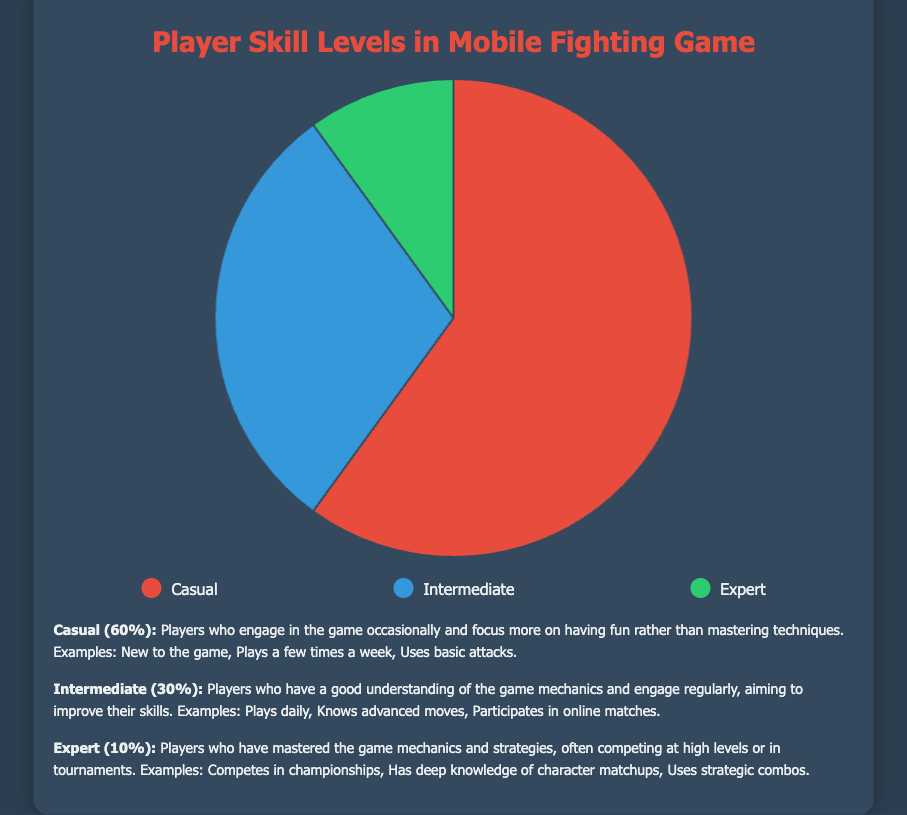Which skill level has the highest percentage of players? By examining the pie chart, it is evident that the "Casual" category is the largest segment of the pie chart, indicating it has the highest percentage.
Answer: Casual What percentage of players are either Intermediate or Expert? To find the combined percentage of Intermediate and Expert players, add their respective percentages: 30% (Intermediate) + 10% (Expert) = 40%.
Answer: 40% How much smaller is the percentage of Expert players compared to Casual players? Subtract the percentage of Expert players from Casual players: 60% (Casual) - 10% (Expert) = 50%.
Answer: 50% Which skill level is represented by the green color in the chart? Observing the pie chart legend, the green color corresponds to the "Expert" category.
Answer: Expert What is the ratio of Casual players to Intermediate players? The ratio can be determined by dividing the percentage of Casual players by the percentage of Intermediate players: 60% / 30% = 2:1.
Answer: 2:1 What’s the total percentage of players who are not Casual? To find the percentage of non-Casual players, combine the percentages of Intermediate and Expert players: 30% (Intermediate) + 10% (Expert) = 40%.
Answer: 40% Which category has the smallest representation in the player base? From the chart, the "Expert" category is the smallest segment, indicating it has the smallest percentage of players.
Answer: Expert How much greater is the percentage of Casual players than the combined percentage of Intermediate and Expert players? To find the difference, subtract the combined percentage of Intermediate and Expert players from the percentage of Casual players: 60% (Casual) - (30% + 10%) = 60% - 40% = 20%.
Answer: 20% If the percentages were doubled, what would be the new percentage for Intermediate players? Doubling the percentage of Intermediate players results in 30% * 2 = 60%.
Answer: 60% If an additional category "Pro" were introduced with 5% of players, what would be the new percentage of Expert players among players excluding "Pro"? Excluding the "Pro" category, the total percentage is 100% - 5% = 95%. The new percentage of Expert players is (10% / 95%) * 100% ≈ 10.53%.
Answer: 10.53% 